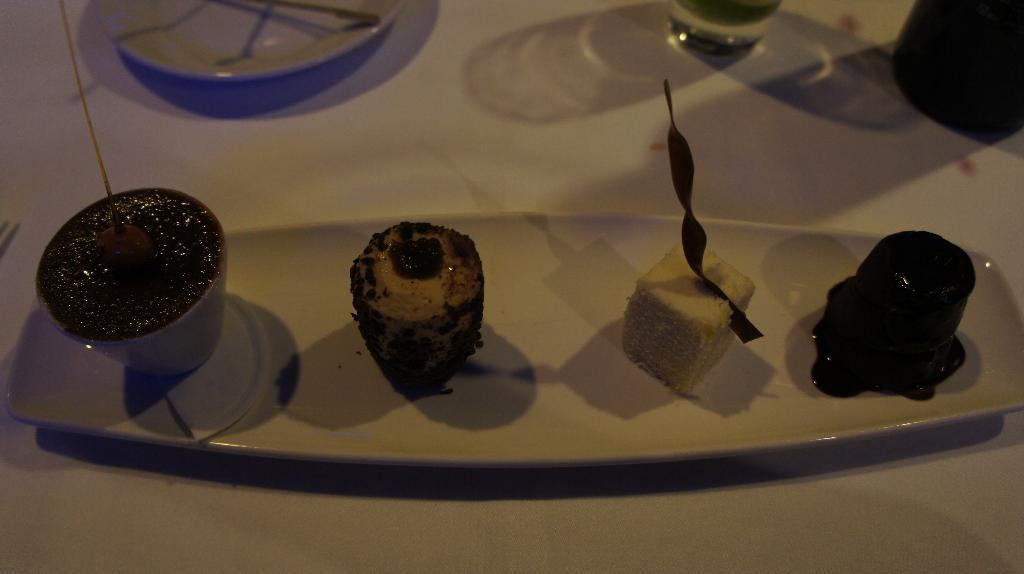What is arranged on the plate in the image? There are food items arranged on a plate in the image. What is located in front of the plate with food items? There is another plate in front of the plate with food items. What is located in front of the plate with food items and the other plate? There is a glass in front of the plate with food items and the other plate. What other objects can be seen in the image? There are other objects visible in the image. Where is the branch located in the image? There is no branch present in the image. 